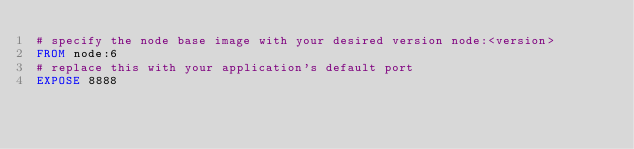Convert code to text. <code><loc_0><loc_0><loc_500><loc_500><_Dockerfile_># specify the node base image with your desired version node:<version>
FROM node:6
# replace this with your application's default port
EXPOSE 8888
</code> 